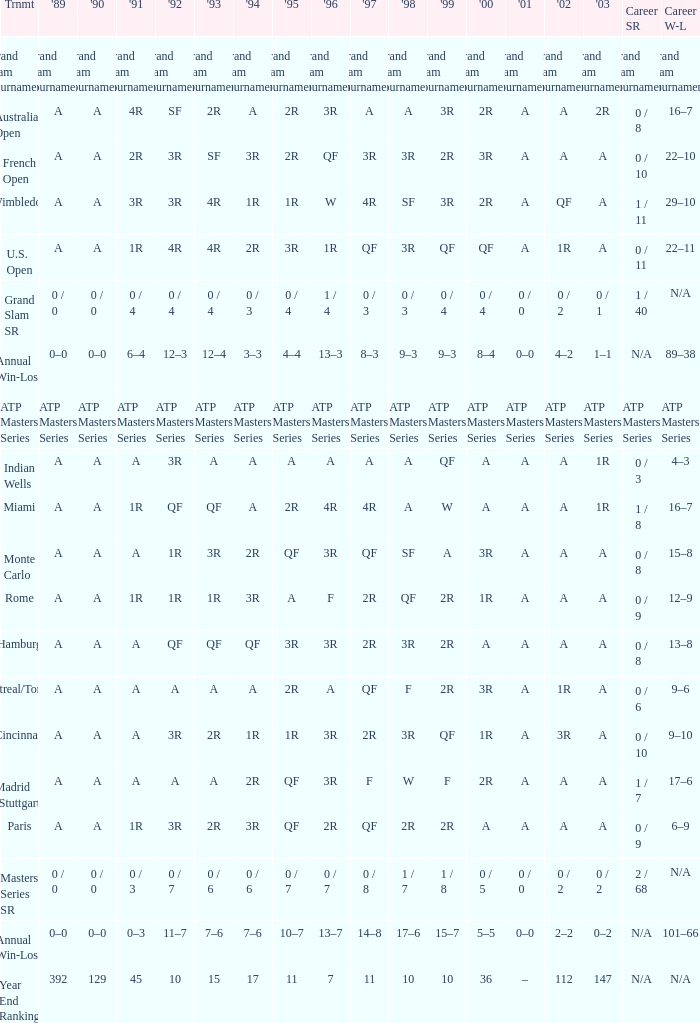What was the 1997 value when 2002 was A and 2003 was 1R? A, 4R. 